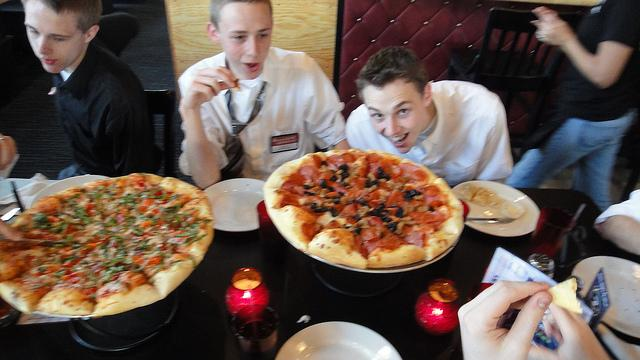What setting is the outfit of the boy sitting in the middle usually found? school 